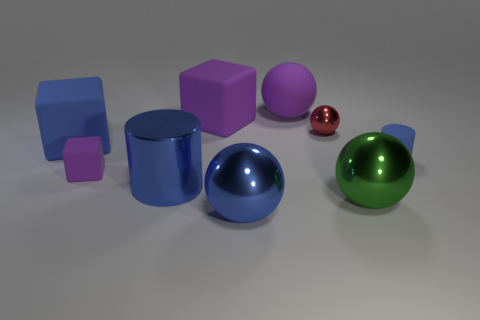Subtract all purple rubber cubes. How many cubes are left? 1 Subtract 1 cylinders. How many cylinders are left? 1 Add 1 tiny gray shiny balls. How many objects exist? 10 Subtract all spheres. How many objects are left? 5 Subtract all blue blocks. How many blocks are left? 2 Subtract all green balls. Subtract all large green metallic balls. How many objects are left? 7 Add 6 big blue metal things. How many big blue metal things are left? 8 Add 4 tiny purple metallic spheres. How many tiny purple metallic spheres exist? 4 Subtract 1 purple cubes. How many objects are left? 8 Subtract all yellow spheres. Subtract all purple blocks. How many spheres are left? 4 